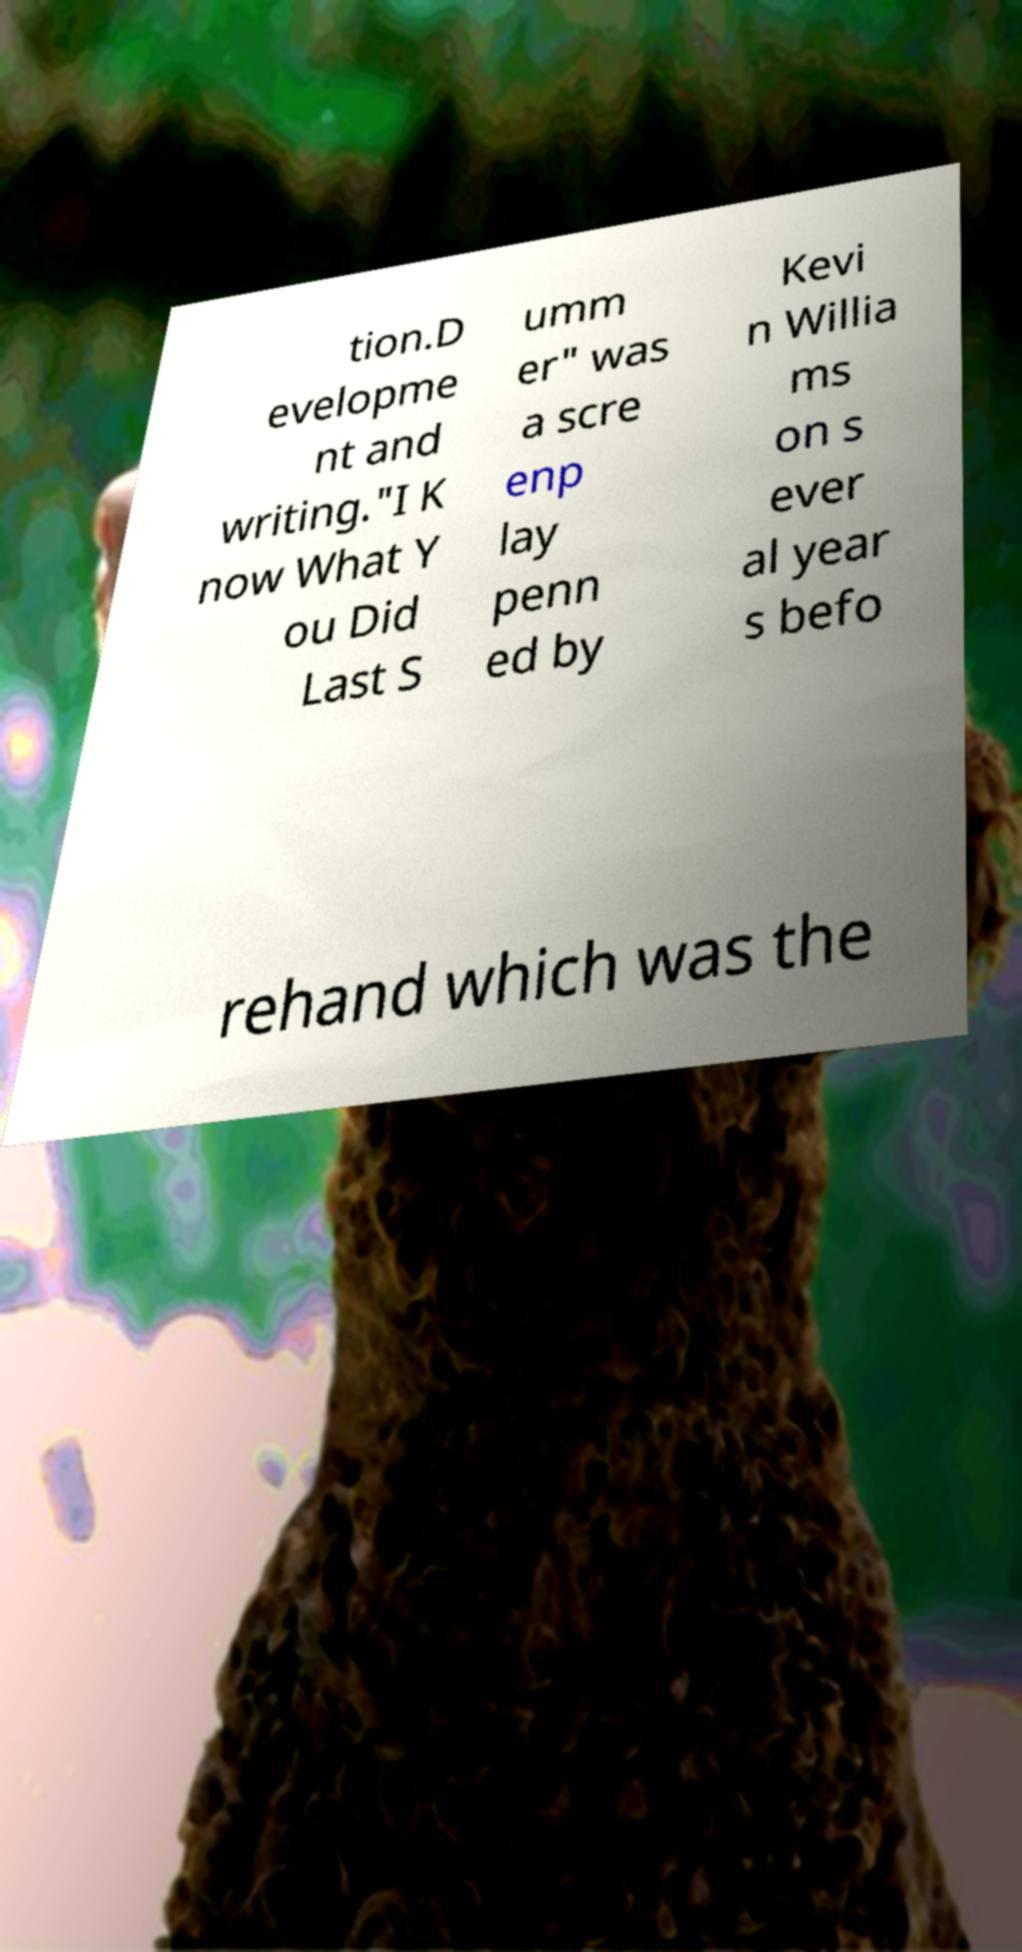Can you read and provide the text displayed in the image?This photo seems to have some interesting text. Can you extract and type it out for me? tion.D evelopme nt and writing."I K now What Y ou Did Last S umm er" was a scre enp lay penn ed by Kevi n Willia ms on s ever al year s befo rehand which was the 